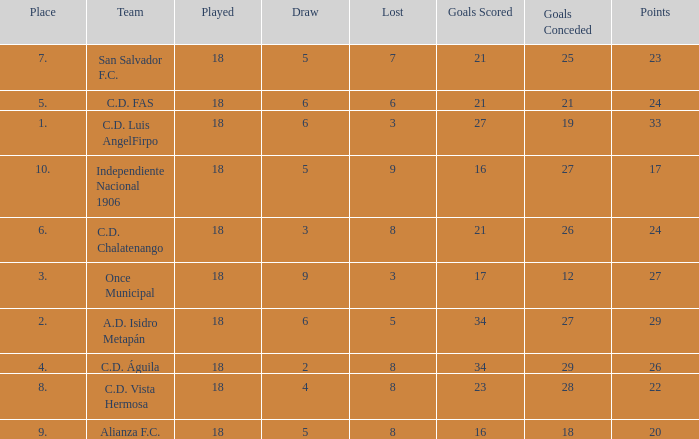For Once Municipal, what were the goals scored that had less than 27 points and greater than place 1? None. 